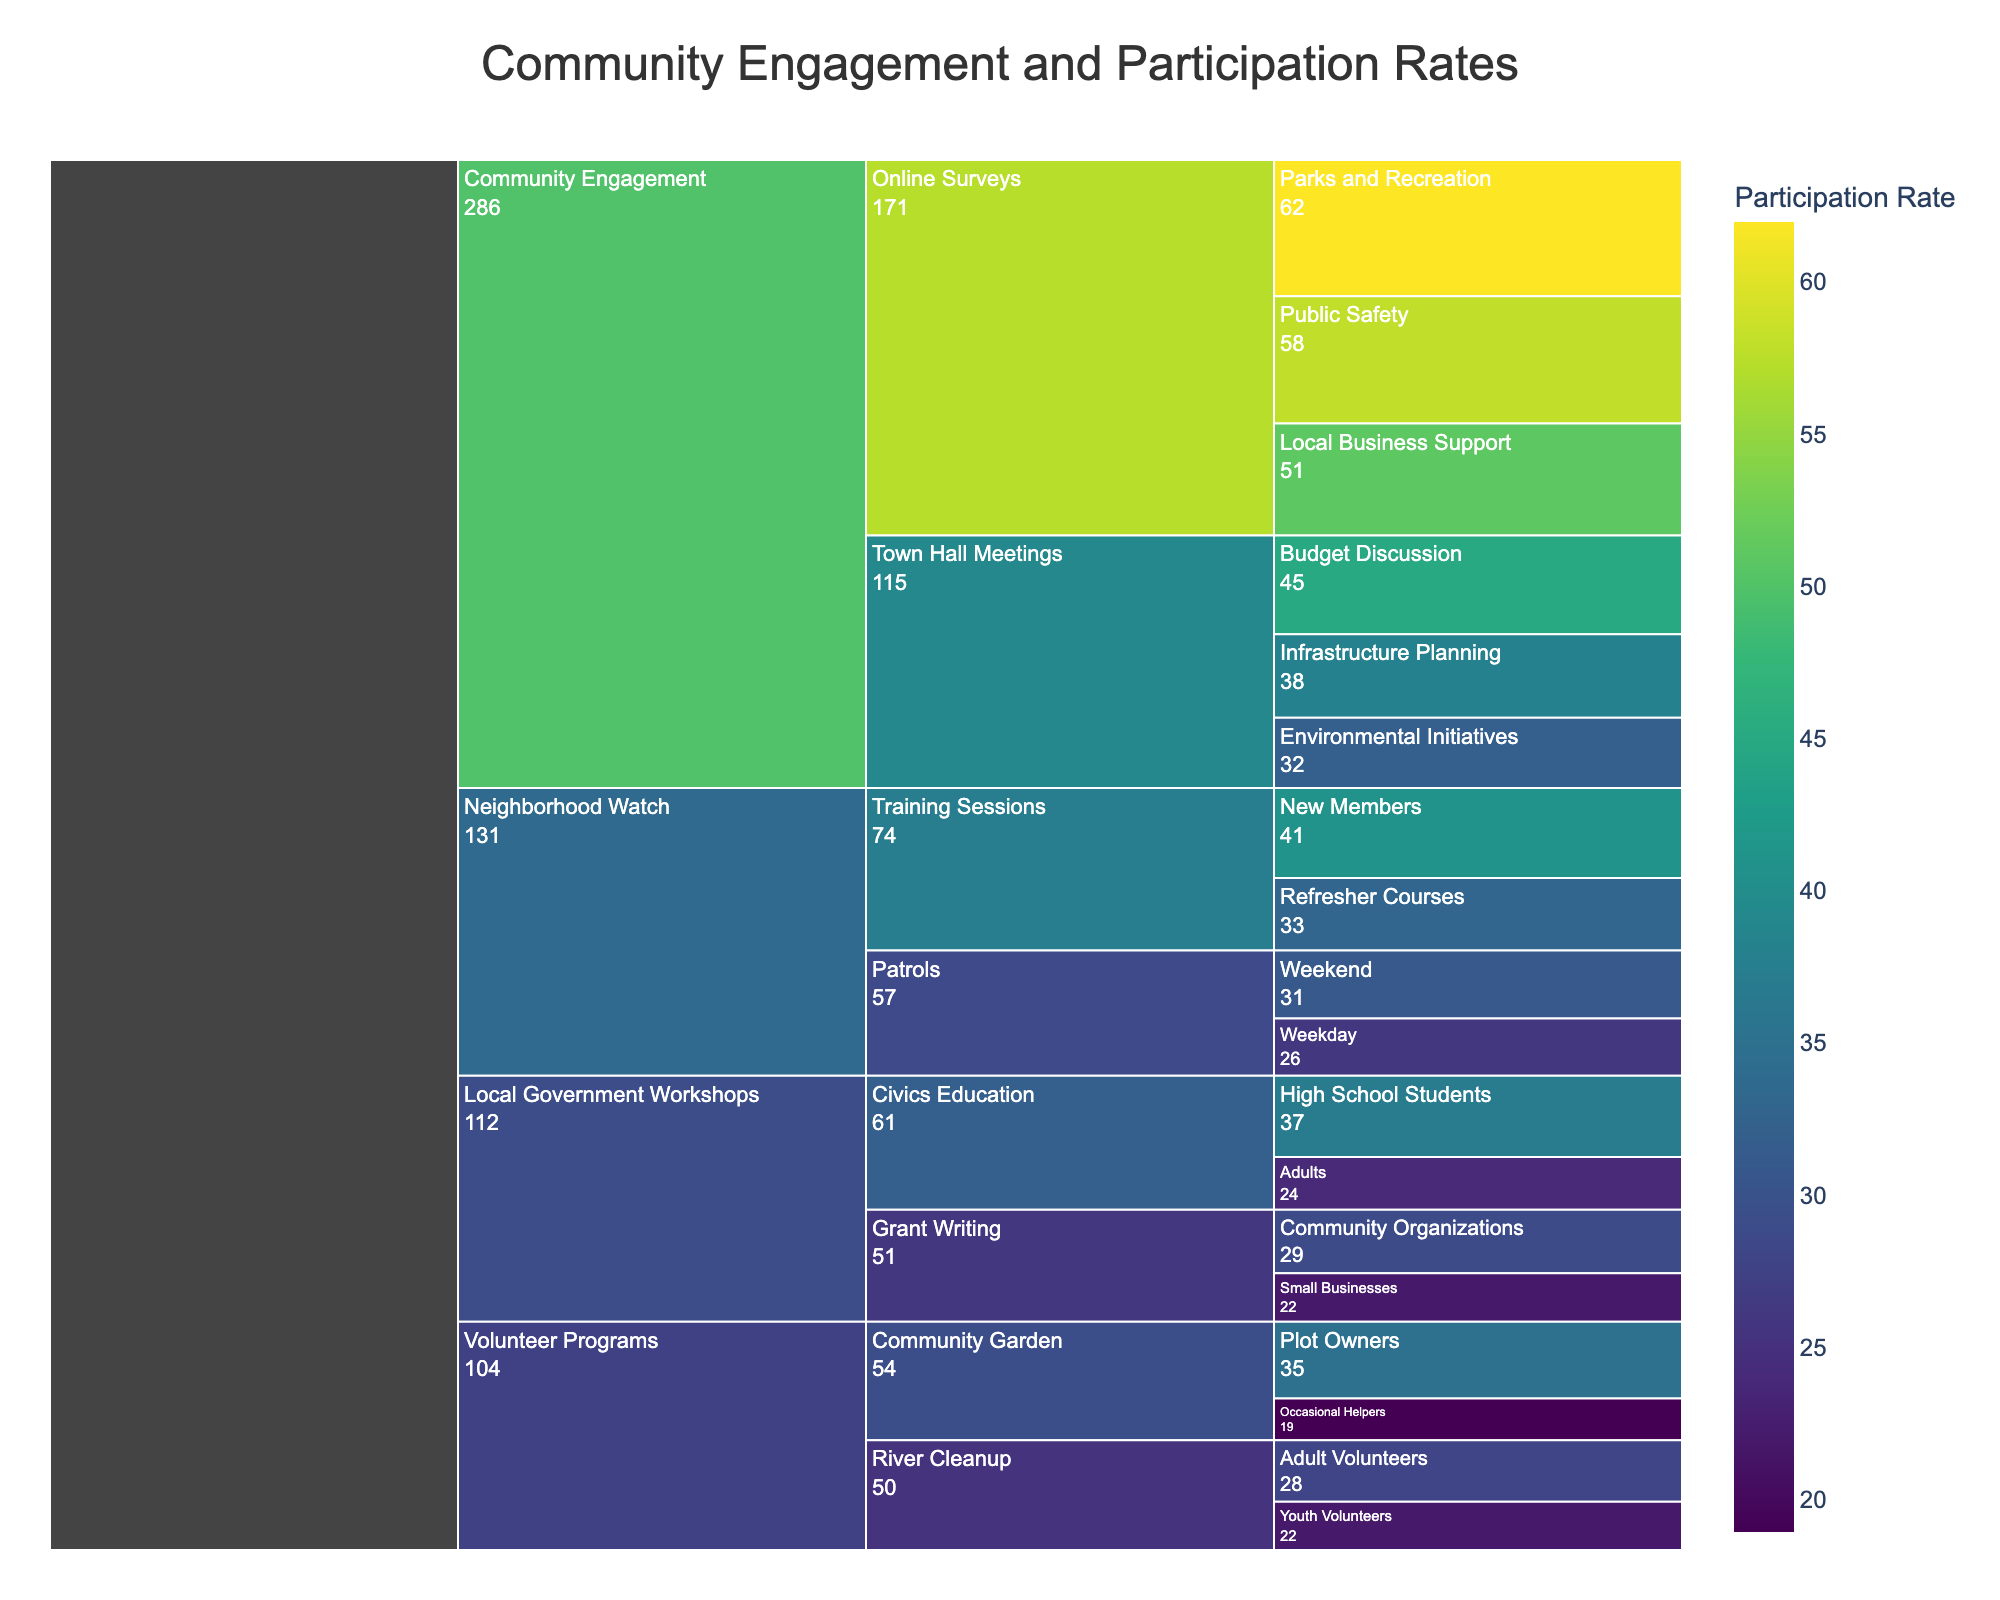what is the title of the Icicle Chart? The title is prominently displayed at the top of the chart. It reads: "Community Engagement and Participation Rates".
Answer: Community Engagement and Participation Rates Which subcategory within "Town Hall Meetings" has the highest participation rate? Within the "Town Hall Meetings" category, the subcategories are "Budget Discussion", "Infrastructure Planning", and "Environmental Initiatives". By examining the participation rates, it's clear that "Budget Discussion" has the highest participation rate at 45%.
Answer: Budget Discussion What is the average participation rate for "Online Surveys"? The subcategories under "Online Surveys" have participation rates of 62%, 58%, and 51%. Adding these together (62 + 58 + 51) and then dividing by 3 gives the average participation rate: (62 + 58 + 51) / 3 = 171 / 3 = 57%.
Answer: 57% Which program has the lowest individual participation rate? To find this, look at the lowest participation rate across all subcategories. "Volunteer Programs - Community Garden - Occasional Helpers" has the lowest individual participation rate at 19%.
Answer: Volunteer Programs - Community Garden - Occasional Helpers Compare the participation rates of "Adult Volunteers" and "Youth Volunteers" in the "River Cleanup" category. Which is higher? In the "River Cleanup" category, "Adult Volunteers" have a participation rate of 28% and "Youth Volunteers" have a participation rate of 22%. Therefore, "Adult Volunteers" have a higher participation rate.
Answer: Adult Volunteers What is the overall participation rate for the "Neighborhood Watch" program? The "Neighborhood Watch" program includes "Training Sessions" and "Patrols". Adding the participation rates for all subcategories (41 + 33 + 26 + 31) gives 131. There are 4 subcategories, so the overall participation rate is 131 / 4 = 32.75%.
Answer: 32.75% What is the participation rate for "High School Students" in "Civics Education"? To find this, look at the "Local Government Workshops" program under "Civics Education". The participation rate for "High School Students" is 37%.
Answer: 37% Which subcategory within "Grant Writing" has a lower participation rate, "Community Organizations" or "Small Businesses"? Under the "Grant Writing" category, "Community Organizations" has a participation rate of 29%, and "Small Businesses" has a participation rate of 22%. Therefore, "Small Businesses" has the lower participation rate.
Answer: Small Businesses How many subcategories have a participation rate above 50%? By examining all subcategories, those with participation rates above 50% include: "Parks and Recreation" (62%) and "Public Safety" (58%). Therefore, there are 2 subcategories with a participation rate above 50%.
Answer: 2 